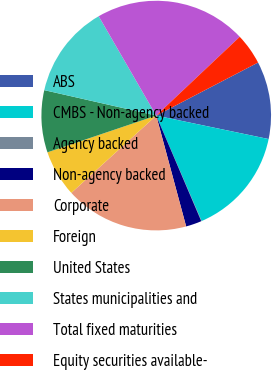Convert chart to OTSL. <chart><loc_0><loc_0><loc_500><loc_500><pie_chart><fcel>ABS<fcel>CMBS - Non-agency backed<fcel>Agency backed<fcel>Non-agency backed<fcel>Corporate<fcel>Foreign<fcel>United States<fcel>States municipalities and<fcel>Total fixed maturities<fcel>Equity securities available-<nl><fcel>10.92%<fcel>15.26%<fcel>0.05%<fcel>2.22%<fcel>17.44%<fcel>6.57%<fcel>8.74%<fcel>13.09%<fcel>21.32%<fcel>4.39%<nl></chart> 